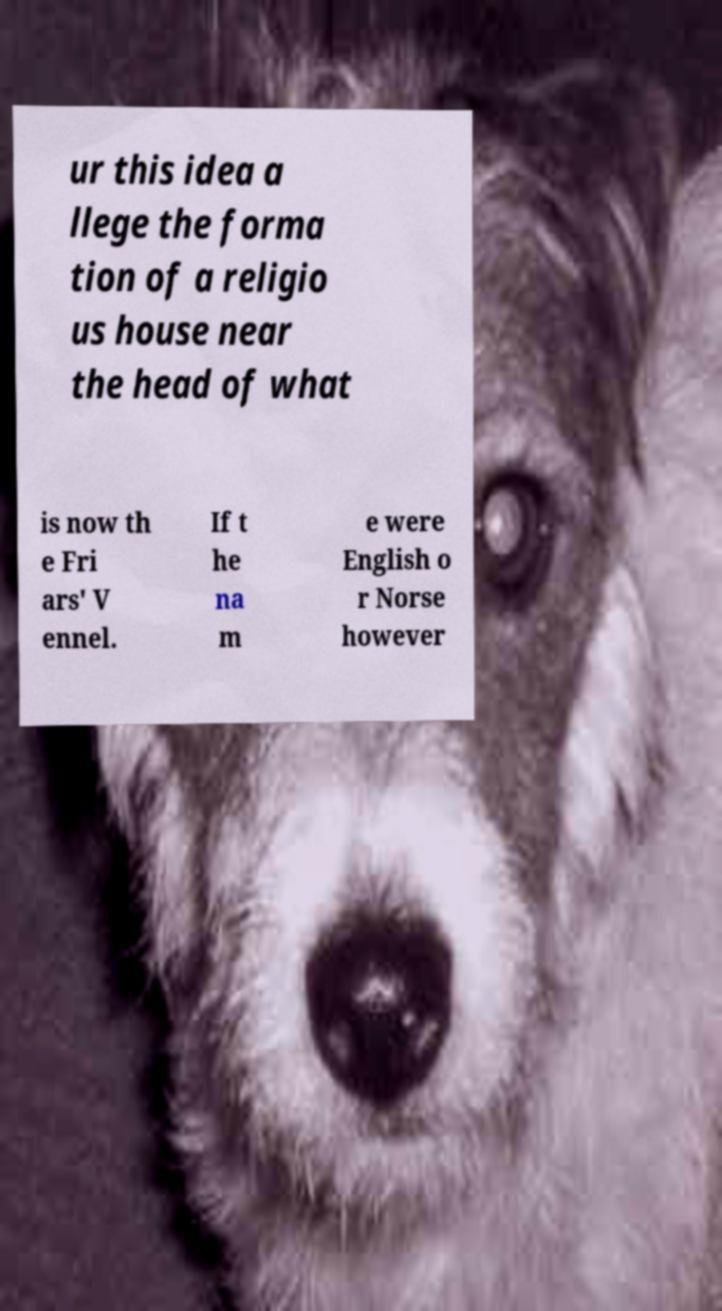What messages or text are displayed in this image? I need them in a readable, typed format. ur this idea a llege the forma tion of a religio us house near the head of what is now th e Fri ars' V ennel. If t he na m e were English o r Norse however 